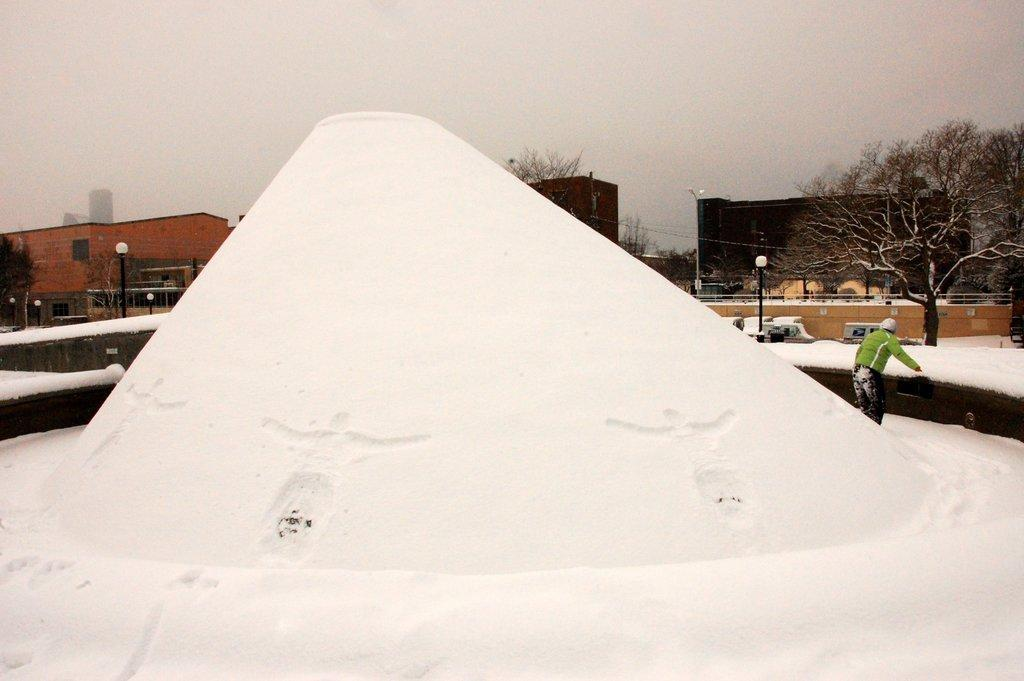What is the primary feature of the environment in the image? The image contains snow. Can you describe the person in the image? There is a person in the image. What structures are present in the image? There are poles, lights, trees, and buildings in the image. What is visible in the background of the image? The sky is visible in the background of the image. What type of bath can be seen in the image? There is no bath present in the image. How many clouds are visible in the image? The provided facts do not mention any clouds in the image. 